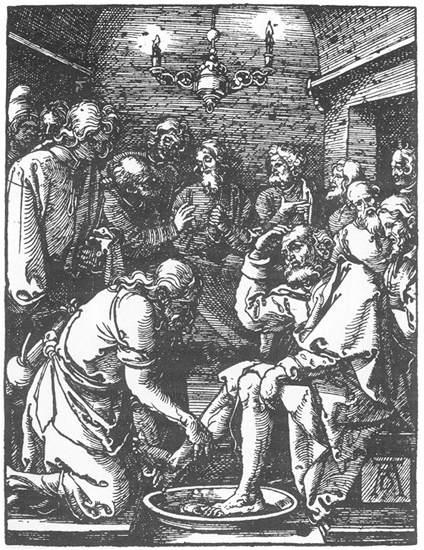Imagine if this scene were part of a larger story. What might the next events be in this story? If we continue from this scene, which is likely depicting Jesus washing his disciples' feet, the next part of the story would likely involve Jesus explaining the significance of his actions. He would teach his disciples about service, humility, and the importance of serving others selflessly. Following this intimate lesson, the narrative might lead to the Last Supper, where Jesus shares bread and wine with his disciples, symbolizing his body and blood, establishing what Christians observe as Communion. This sequence of events is deeply tied to Holy Week and precedes the events leading to Jesus' crucifixion and resurrection. What can you tell me about the architectural details in the background of this illustration? The background of this illustration reveals a room constructed of brick walls, lending an earthy and sturdy ambiance to the setting. The chandelier hanging from the ceiling suggests a space of significance or importance, as such fixtures often adorn notable buildings or places of gathering. The arches and overall structure hint at an older architectural style, possibly medieval or early Renaissance, aligning with the historical period the scene aims to represent. These elements combine to create an atmosphere of historical depth and cultural richness. 